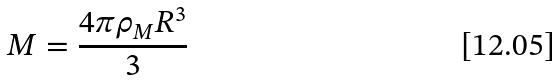Convert formula to latex. <formula><loc_0><loc_0><loc_500><loc_500>M = \frac { 4 \pi \rho _ { M } R ^ { 3 } } { 3 }</formula> 